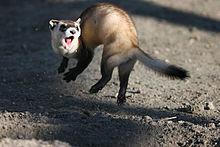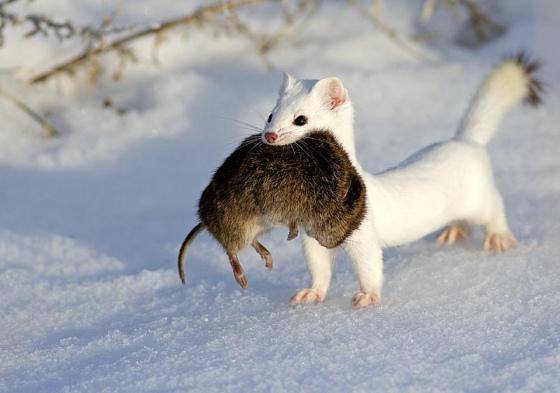The first image is the image on the left, the second image is the image on the right. Given the left and right images, does the statement "The left image shows one ferret emerging from a hole in the ground, and the right image contains multiple ferrets." hold true? Answer yes or no. No. The first image is the image on the left, the second image is the image on the right. Assess this claim about the two images: "There is at least two prairie dogs in the right image.". Correct or not? Answer yes or no. No. 